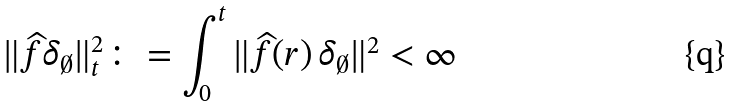Convert formula to latex. <formula><loc_0><loc_0><loc_500><loc_500>\| \widehat { f } \delta _ { \emptyset } \| _ { t } ^ { 2 } \colon = \int _ { 0 } ^ { t } \| \widehat { f } ( r ) \, \delta _ { \emptyset } \| ^ { 2 } < \infty</formula> 